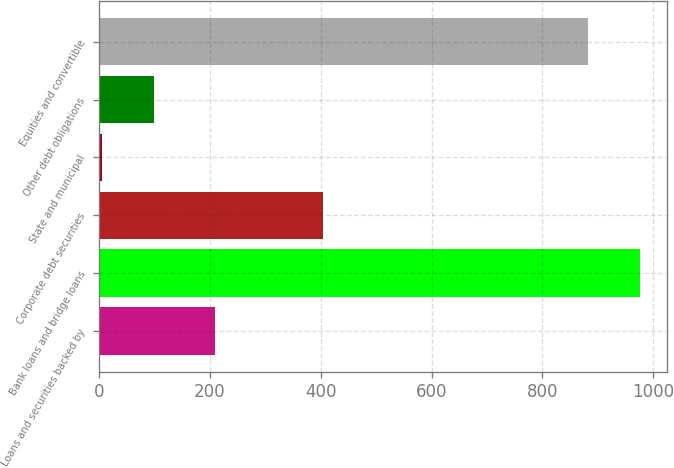<chart> <loc_0><loc_0><loc_500><loc_500><bar_chart><fcel>Loans and securities backed by<fcel>Bank loans and bridge loans<fcel>Corporate debt securities<fcel>State and municipal<fcel>Other debt obligations<fcel>Equities and convertible<nl><fcel>209<fcel>975.6<fcel>404<fcel>6<fcel>99.6<fcel>882<nl></chart> 